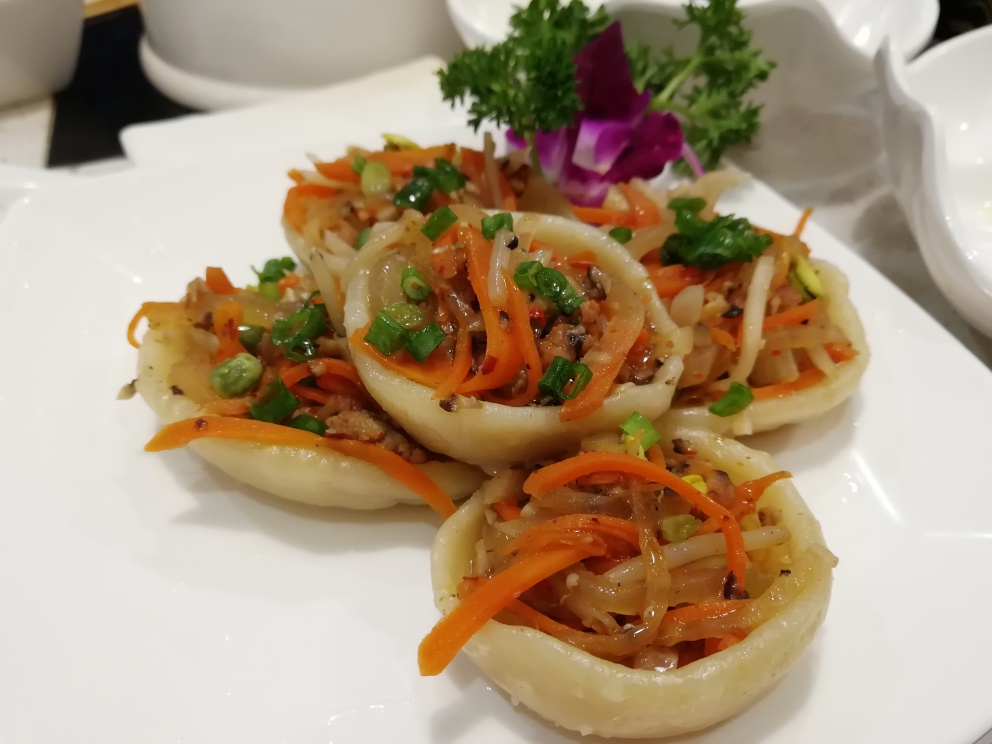What can be said about the quality of this image?
A. Mediocre
B. Excellent.
C. Unsatisfactory The quality of the image can be considered excellent (Option B). The subjects of the photo, which appear to be an array of meticulously prepared dishes, are in sharp focus, with vibrant colors and fine details clearly visible. The lighting in the image is well-balanced, highlighting the textures and contributing to the overall appealing presentation of the food. 